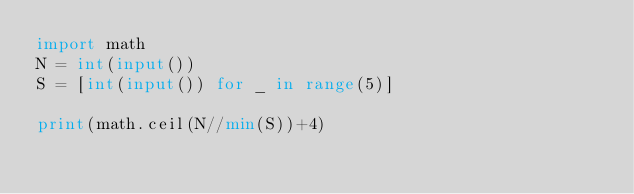Convert code to text. <code><loc_0><loc_0><loc_500><loc_500><_Python_>import math
N = int(input())
S = [int(input()) for _ in range(5)]

print(math.ceil(N//min(S))+4)


</code> 